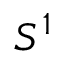<formula> <loc_0><loc_0><loc_500><loc_500>S ^ { 1 }</formula> 